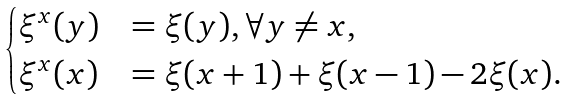<formula> <loc_0><loc_0><loc_500><loc_500>\begin{cases} \xi ^ { x } ( y ) & = \xi ( y ) , \forall y \ne x , \\ \xi ^ { x } ( x ) & = \xi ( x + 1 ) + \xi ( x - 1 ) - 2 \xi ( x ) . \end{cases}</formula> 